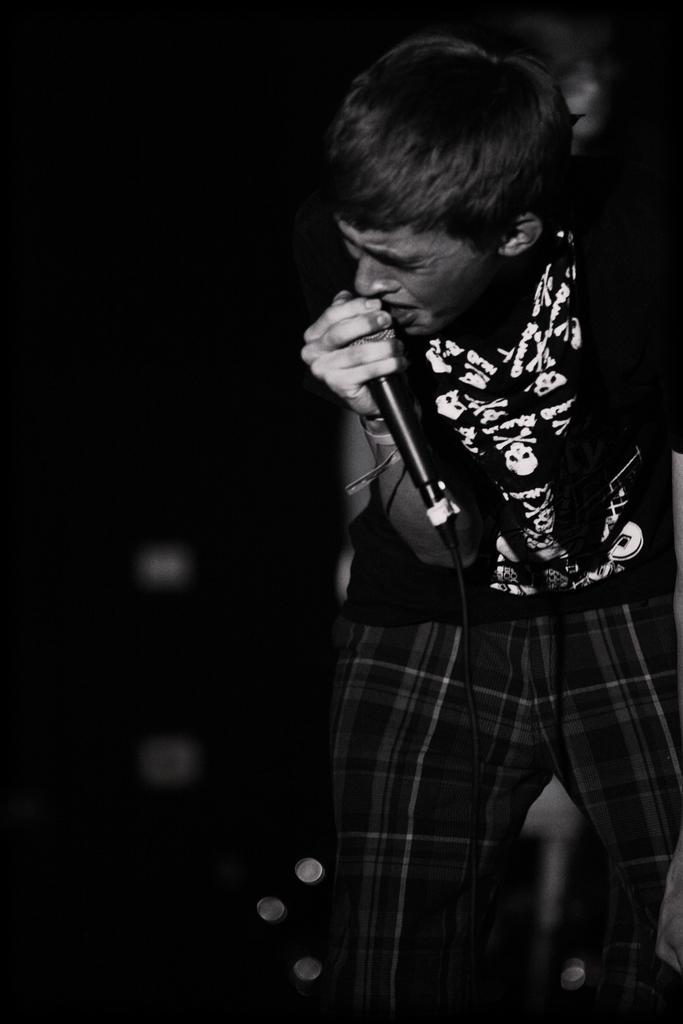Could you give a brief overview of what you see in this image? In the image we can see there is a person who is holding mic in his hand and the image is in black and white colour. 